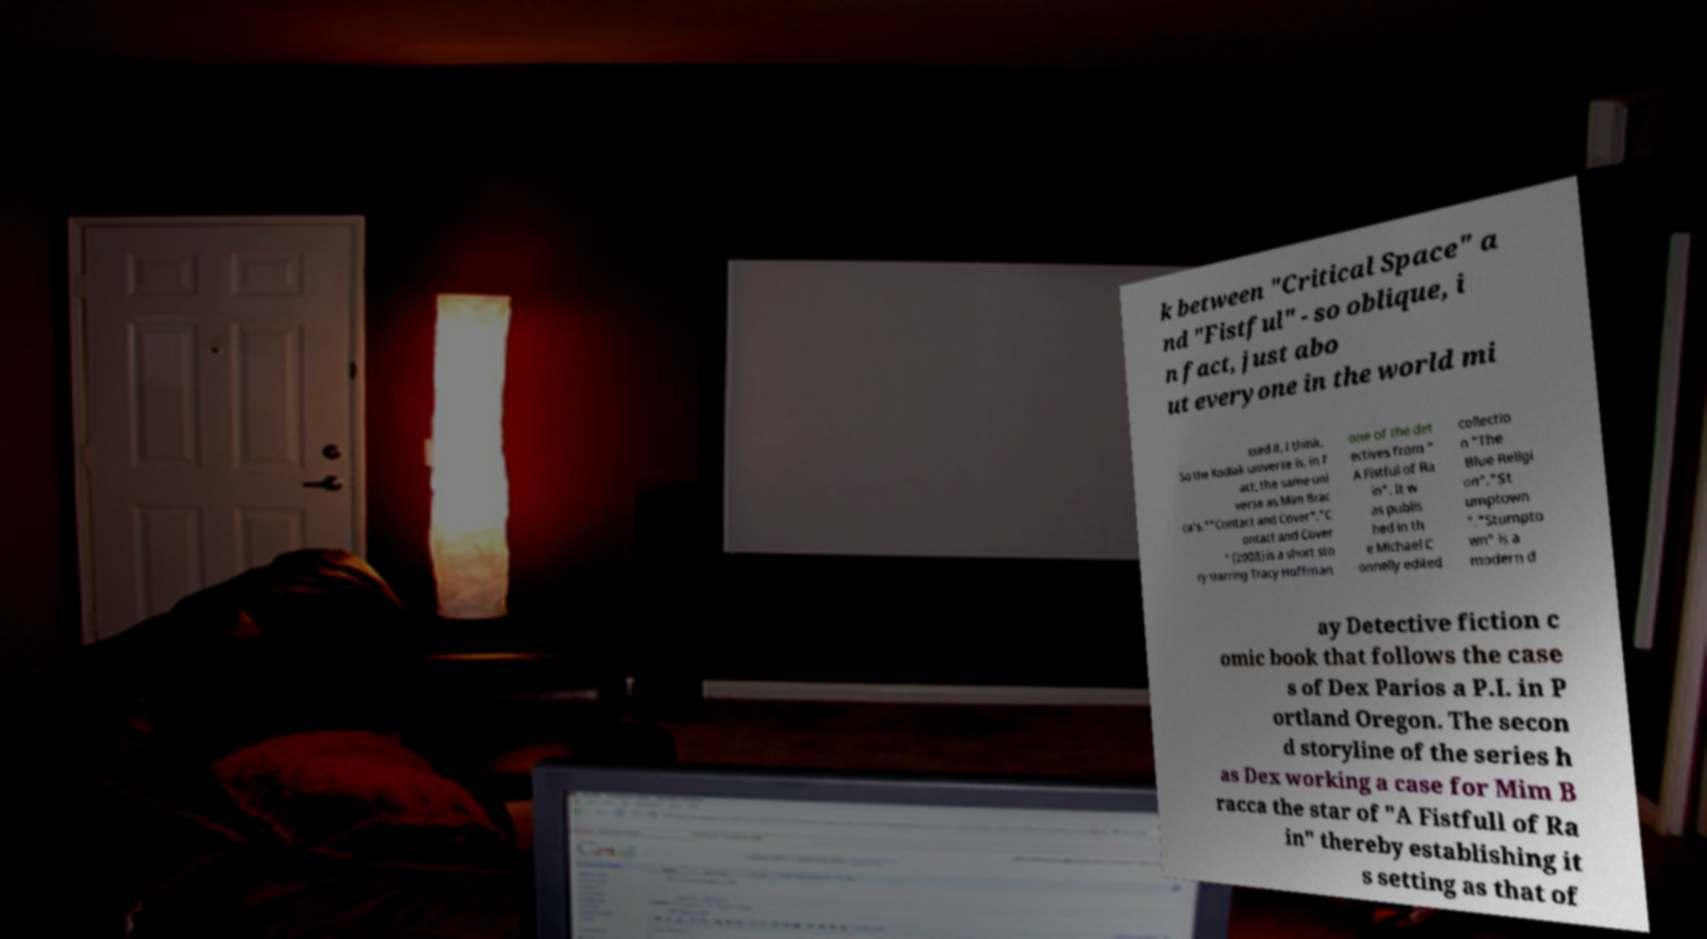Can you read and provide the text displayed in the image?This photo seems to have some interesting text. Can you extract and type it out for me? k between "Critical Space" a nd "Fistful" - so oblique, i n fact, just abo ut everyone in the world mi ssed it, I think. So the Kodiak universe is, in f act, the same uni verse as Mim Brac ca's.""Contact and Cover"."C ontact and Cover " (2008) is a short sto ry starring Tracy Hoffman one of the det ectives from " A Fistful of Ra in". It w as publis hed in th e Michael C onnelly edited collectio n "The Blue Religi on"."St umptown "."Stumpto wn" is a modern d ay Detective fiction c omic book that follows the case s of Dex Parios a P.I. in P ortland Oregon. The secon d storyline of the series h as Dex working a case for Mim B racca the star of "A Fistfull of Ra in" thereby establishing it s setting as that of 